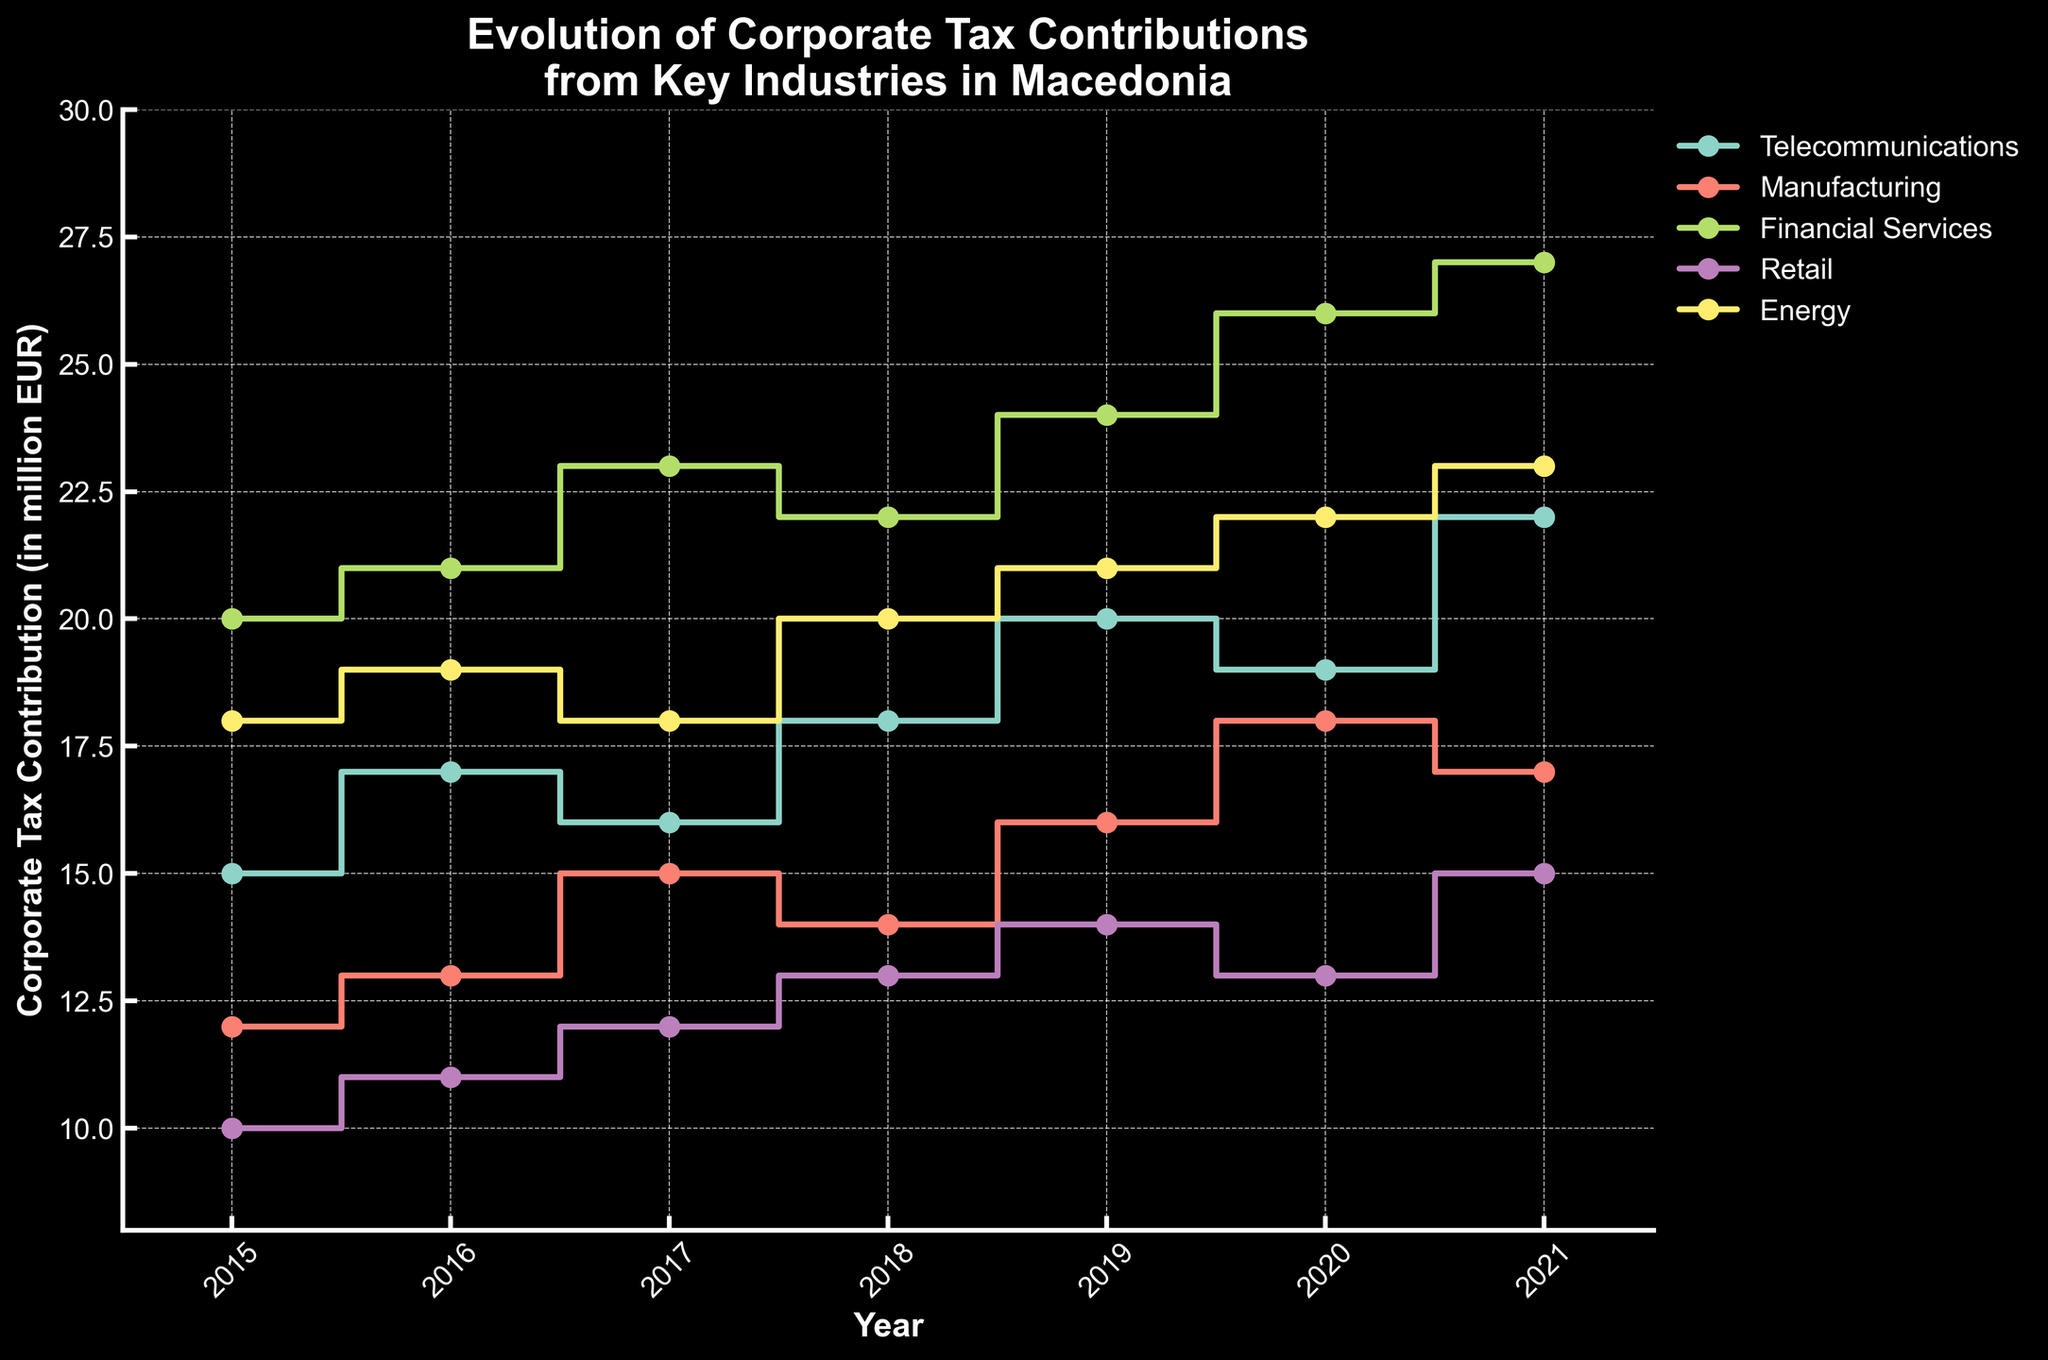What is the title of the plot? The title of the plot is usually at the top of the figure and provides a summary of what is being displayed.
Answer: Evolution of Corporate Tax Contributions from Key Industries in Macedonia What is the Corporate Tax Contribution for Telecommunications in 2021? Telecommunications data points are connected by the same color line with markers. Follow the line for Telecommunications and locate the value for 2021.
Answer: 22 million EUR Which industry had the highest Corporate Tax Contribution in 2020? Compare the values for each industry in the year 2020. The tallest step in 2020 will indicate the industry with the highest contribution.
Answer: Financial Services What was the overall trend for the Retail industry from 2015 to 2021? Look at the step plot for the Retail industry, observing the general direction of the steps from 2015 to 2021.
Answer: Upward, despite a slight decrease in 2020 By how much did the Corporate Tax Contribution for Manufacturing change from 2017 to 2018? Find the contribution value for Manufacturing in 2017 and 2018, then subtract the earlier value from the later value.
Answer: -1 million EUR Which year saw the largest increase in Corporate Tax Contributions for the Energy industry? Identify the years where the steps in the Energy industry plot show increases and compare their differences.
Answer: 2016 to 2017 How many industries experienced continuous growth in their tax contributions from 2015 to 2021? Examine each industry's step plot for continuous upward steps from 2015 to 2021. Count how many industries follow this pattern without any decreases.
Answer: 2 (Financial Services and Energy) Which industry had the least variation in Corporate Tax Contribution over the years? Check each industry's step plot and observe the range of values. The industry with the smallest range or changes is the one with the least variation.
Answer: Telecommunications What was the combined Corporate Tax Contribution for Retail and Telecommunications in 2019? Add the Corporate Tax Contributions of Retail and Telecommunications for the year 2019.
Answer: 34 million EUR What is the average Corporate Tax Contribution for the Manufacturing industry across all years shown? Sum the Corporate Tax Contributions of Manufacturing from 2015 to 2021 and divide by the number of years (7).
Answer: 15 million EUR 